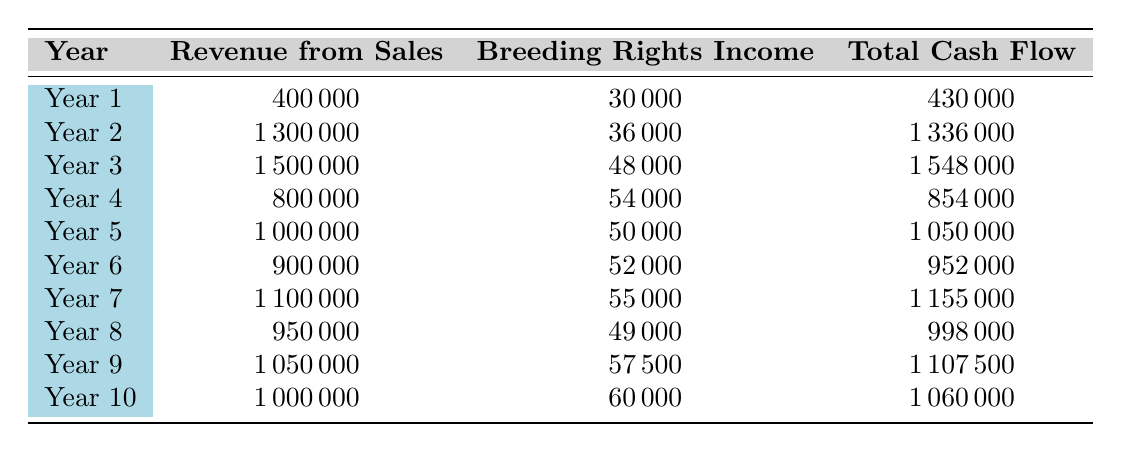What is the total cash flow in Year 3? According to the table, the total cash flow for Year 3 is explicitly listed as 1548000.
Answer: 1548000 Which year has the highest revenue from sales? By examining the revenue from sales column, Year 3 has 1500000, which is higher than all other years' revenue from sales.
Answer: Year 3 What is the difference in total cash flow between Year 2 and Year 4? The total cash flow for Year 2 is 1336000 and for Year 4 is 854000. The difference is 1336000 - 854000 = 482000.
Answer: 482000 Is the breeding rights income in Year 5 greater than that in Year 8? The breeding rights income in Year 5 is 50000, while in Year 8 it is 49000. Since 50000 is indeed greater than 49000, the answer is yes.
Answer: Yes What is the average total cash flow over the 10 years? To find the average total cash flow, we sum all total cash flows from Year 1 to Year 10: 430000 + 1336000 + 1548000 + 854000 + 1050000 + 952000 + 1155000 + 998000 + 1107500 + 1060000 = 10484000. Then, divide by 10: 10484000 / 10 = 1048400.
Answer: 1048400 Which year has the lowest breeding rights income? By examining the breeding rights income column, Year 1 has 30000, which is lower than all other years' breeding rights income.
Answer: Year 1 Calculate the total projected revenue from sales over the first decade. Summing the revenue from sales for each year: 400000 + 1300000 + 1500000 + 800000 + 1000000 + 900000 + 1100000 + 950000 + 1050000 + 1000000 = 10300000.
Answer: 10300000 Is there a year where the total cash flow was below 900000? By reviewing the total cash flow for each year, both Year 1 (430000) and Year 4 (854000) are below 900000, so it is true that there are such years.
Answer: Yes 